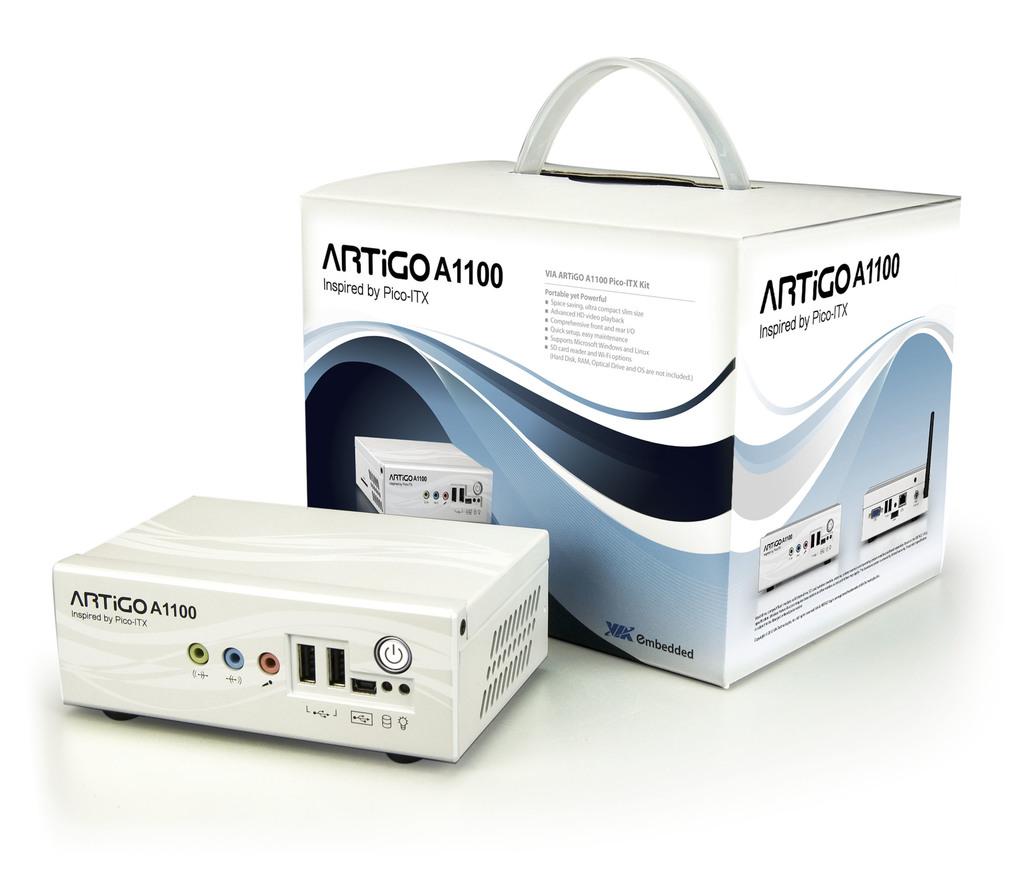What brand of smartphone is this?
Offer a very short reply. Unanswerable. 